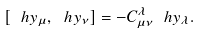<formula> <loc_0><loc_0><loc_500><loc_500>[ \ h y _ { \mu } , \ h y _ { \nu } ] = - C _ { \mu \nu } ^ { \lambda } \ h y _ { \lambda } .</formula> 